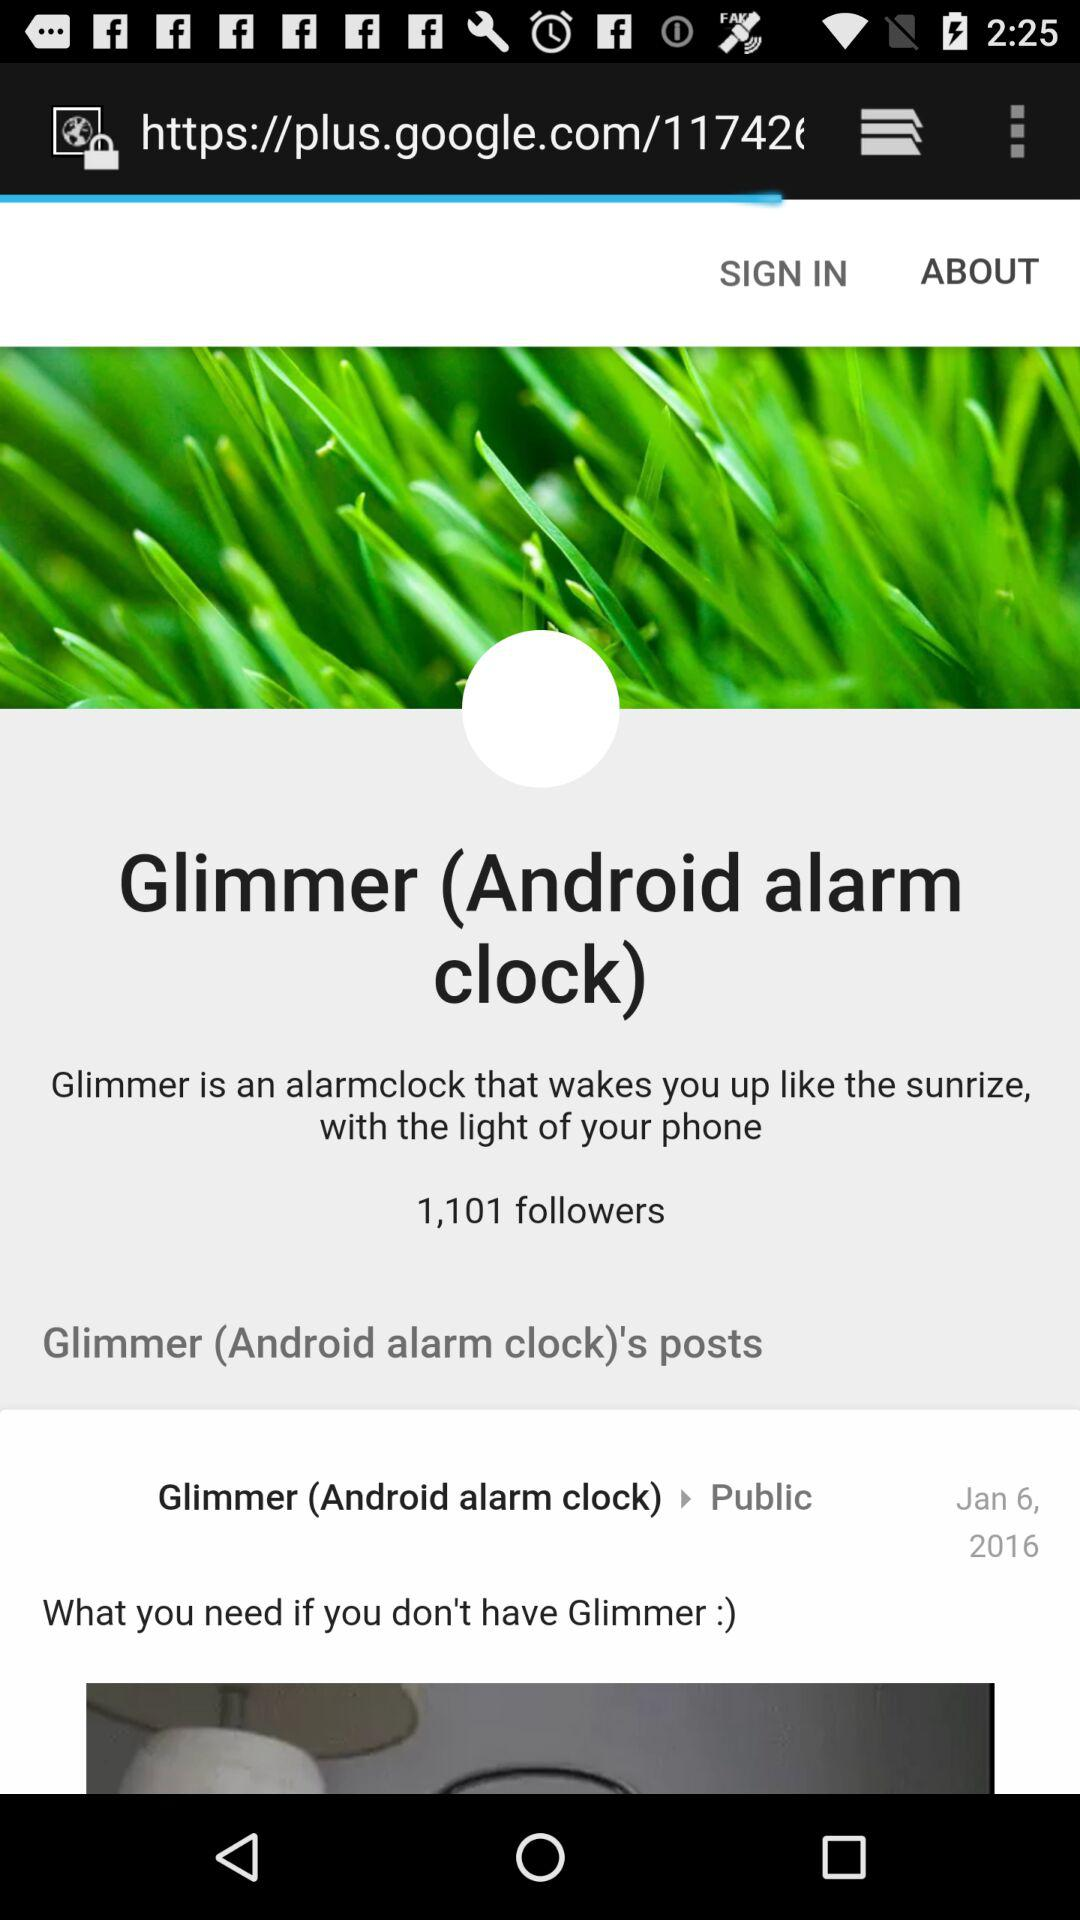How many followers are there? There are 1,101 followers. 